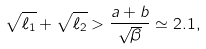<formula> <loc_0><loc_0><loc_500><loc_500>\sqrt { \ell _ { 1 } } + \sqrt { \ell _ { 2 } } > \frac { a + b } { \sqrt { \beta } } \simeq 2 . 1 ,</formula> 